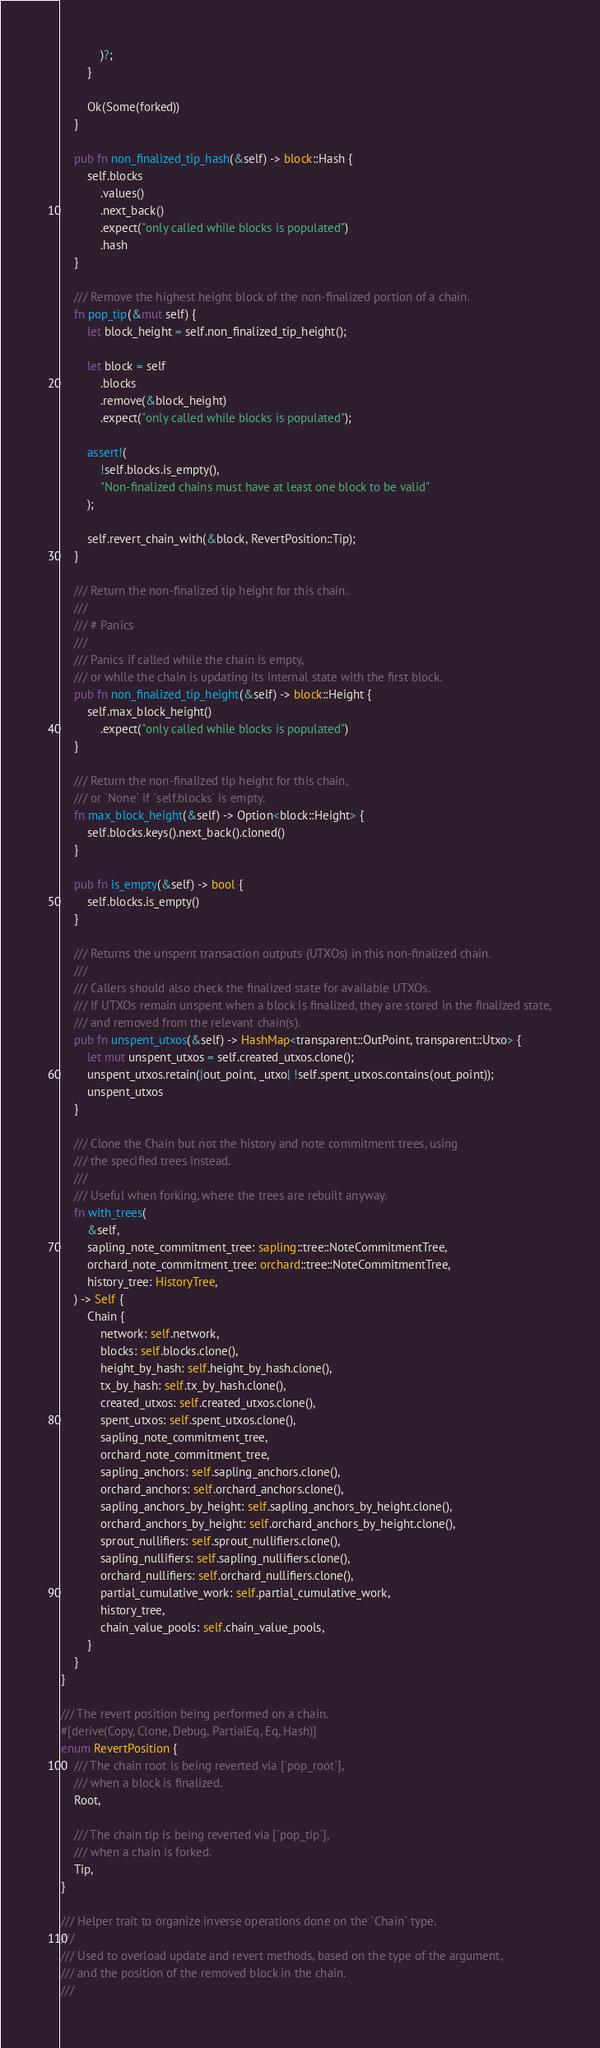<code> <loc_0><loc_0><loc_500><loc_500><_Rust_>            )?;
        }

        Ok(Some(forked))
    }

    pub fn non_finalized_tip_hash(&self) -> block::Hash {
        self.blocks
            .values()
            .next_back()
            .expect("only called while blocks is populated")
            .hash
    }

    /// Remove the highest height block of the non-finalized portion of a chain.
    fn pop_tip(&mut self) {
        let block_height = self.non_finalized_tip_height();

        let block = self
            .blocks
            .remove(&block_height)
            .expect("only called while blocks is populated");

        assert!(
            !self.blocks.is_empty(),
            "Non-finalized chains must have at least one block to be valid"
        );

        self.revert_chain_with(&block, RevertPosition::Tip);
    }

    /// Return the non-finalized tip height for this chain.
    ///
    /// # Panics
    ///
    /// Panics if called while the chain is empty,
    /// or while the chain is updating its internal state with the first block.
    pub fn non_finalized_tip_height(&self) -> block::Height {
        self.max_block_height()
            .expect("only called while blocks is populated")
    }

    /// Return the non-finalized tip height for this chain,
    /// or `None` if `self.blocks` is empty.
    fn max_block_height(&self) -> Option<block::Height> {
        self.blocks.keys().next_back().cloned()
    }

    pub fn is_empty(&self) -> bool {
        self.blocks.is_empty()
    }

    /// Returns the unspent transaction outputs (UTXOs) in this non-finalized chain.
    ///
    /// Callers should also check the finalized state for available UTXOs.
    /// If UTXOs remain unspent when a block is finalized, they are stored in the finalized state,
    /// and removed from the relevant chain(s).
    pub fn unspent_utxos(&self) -> HashMap<transparent::OutPoint, transparent::Utxo> {
        let mut unspent_utxos = self.created_utxos.clone();
        unspent_utxos.retain(|out_point, _utxo| !self.spent_utxos.contains(out_point));
        unspent_utxos
    }

    /// Clone the Chain but not the history and note commitment trees, using
    /// the specified trees instead.
    ///
    /// Useful when forking, where the trees are rebuilt anyway.
    fn with_trees(
        &self,
        sapling_note_commitment_tree: sapling::tree::NoteCommitmentTree,
        orchard_note_commitment_tree: orchard::tree::NoteCommitmentTree,
        history_tree: HistoryTree,
    ) -> Self {
        Chain {
            network: self.network,
            blocks: self.blocks.clone(),
            height_by_hash: self.height_by_hash.clone(),
            tx_by_hash: self.tx_by_hash.clone(),
            created_utxos: self.created_utxos.clone(),
            spent_utxos: self.spent_utxos.clone(),
            sapling_note_commitment_tree,
            orchard_note_commitment_tree,
            sapling_anchors: self.sapling_anchors.clone(),
            orchard_anchors: self.orchard_anchors.clone(),
            sapling_anchors_by_height: self.sapling_anchors_by_height.clone(),
            orchard_anchors_by_height: self.orchard_anchors_by_height.clone(),
            sprout_nullifiers: self.sprout_nullifiers.clone(),
            sapling_nullifiers: self.sapling_nullifiers.clone(),
            orchard_nullifiers: self.orchard_nullifiers.clone(),
            partial_cumulative_work: self.partial_cumulative_work,
            history_tree,
            chain_value_pools: self.chain_value_pools,
        }
    }
}

/// The revert position being performed on a chain.
#[derive(Copy, Clone, Debug, PartialEq, Eq, Hash)]
enum RevertPosition {
    /// The chain root is being reverted via [`pop_root`],
    /// when a block is finalized.
    Root,

    /// The chain tip is being reverted via [`pop_tip`],
    /// when a chain is forked.
    Tip,
}

/// Helper trait to organize inverse operations done on the `Chain` type.
///
/// Used to overload update and revert methods, based on the type of the argument,
/// and the position of the removed block in the chain.
///</code> 